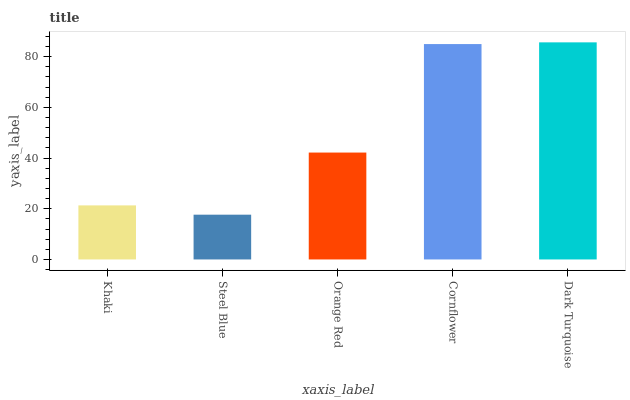Is Steel Blue the minimum?
Answer yes or no. Yes. Is Dark Turquoise the maximum?
Answer yes or no. Yes. Is Orange Red the minimum?
Answer yes or no. No. Is Orange Red the maximum?
Answer yes or no. No. Is Orange Red greater than Steel Blue?
Answer yes or no. Yes. Is Steel Blue less than Orange Red?
Answer yes or no. Yes. Is Steel Blue greater than Orange Red?
Answer yes or no. No. Is Orange Red less than Steel Blue?
Answer yes or no. No. Is Orange Red the high median?
Answer yes or no. Yes. Is Orange Red the low median?
Answer yes or no. Yes. Is Dark Turquoise the high median?
Answer yes or no. No. Is Cornflower the low median?
Answer yes or no. No. 